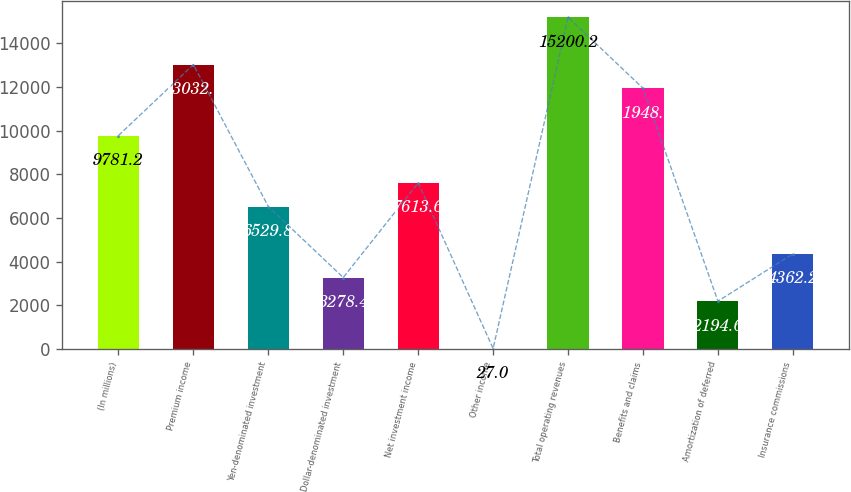<chart> <loc_0><loc_0><loc_500><loc_500><bar_chart><fcel>(In millions)<fcel>Premium income<fcel>Yen-denominated investment<fcel>Dollar-denominated investment<fcel>Net investment income<fcel>Other income<fcel>Total operating revenues<fcel>Benefits and claims<fcel>Amortization of deferred<fcel>Insurance commissions<nl><fcel>9781.2<fcel>13032.6<fcel>6529.8<fcel>3278.4<fcel>7613.6<fcel>27<fcel>15200.2<fcel>11948.8<fcel>2194.6<fcel>4362.2<nl></chart> 